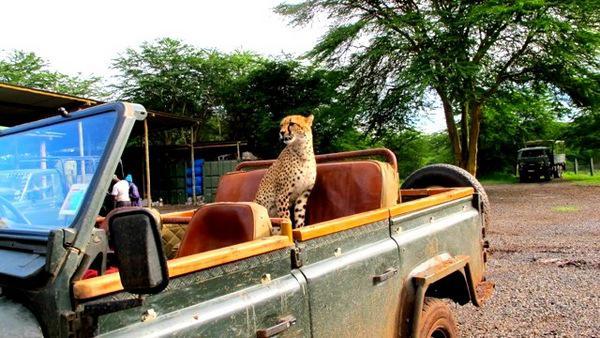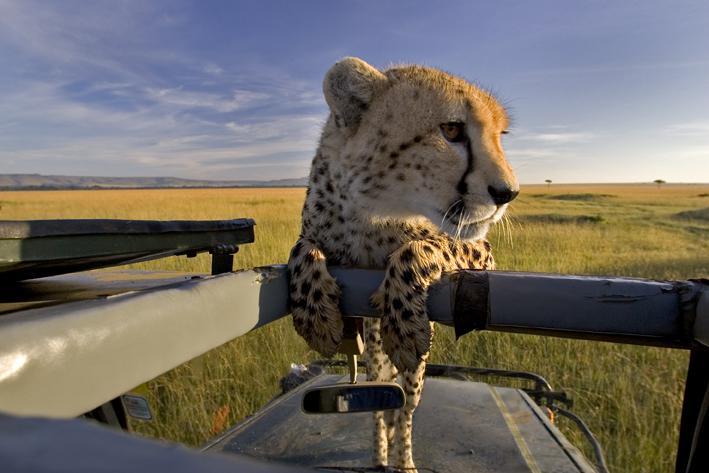The first image is the image on the left, the second image is the image on the right. Evaluate the accuracy of this statement regarding the images: "In one image, a cheetah is on a seat in the vehicle.". Is it true? Answer yes or no. Yes. The first image is the image on the left, the second image is the image on the right. Assess this claim about the two images: "The left image shows a cheetah inside a vehicle perched on the back seat, and the right image shows a cheetah with its body facing the camera, draping its front paws over part of the vehicle's frame.". Correct or not? Answer yes or no. Yes. 